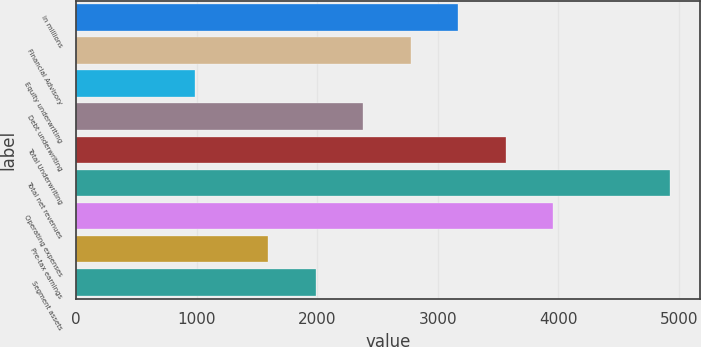<chart> <loc_0><loc_0><loc_500><loc_500><bar_chart><fcel>in millions<fcel>Financial Advisory<fcel>Equity underwriting<fcel>Debt underwriting<fcel>Total Underwriting<fcel>Total net revenues<fcel>Operating expenses<fcel>Pre-tax earnings<fcel>Segment assets<nl><fcel>3168.6<fcel>2774.7<fcel>987<fcel>2380.8<fcel>3562.5<fcel>4926<fcel>3956.4<fcel>1593<fcel>1986.9<nl></chart> 